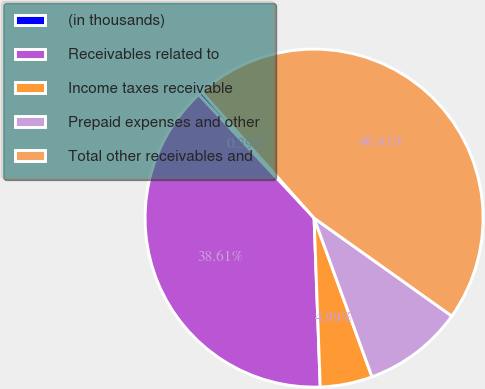Convert chart. <chart><loc_0><loc_0><loc_500><loc_500><pie_chart><fcel>(in thousands)<fcel>Receivables related to<fcel>Income taxes receivable<fcel>Prepaid expenses and other<fcel>Total other receivables and<nl><fcel>0.39%<fcel>38.61%<fcel>4.99%<fcel>9.59%<fcel>46.41%<nl></chart> 